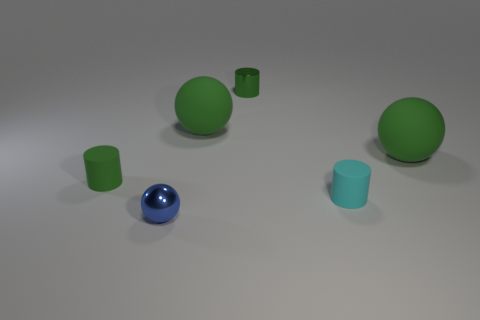What is the big green sphere left of the matte object that is on the right side of the tiny cyan cylinder made of?
Give a very brief answer. Rubber. Is there anything else that is the same size as the green rubber cylinder?
Your answer should be very brief. Yes. Do the cyan cylinder and the green cylinder that is to the right of the blue thing have the same material?
Ensure brevity in your answer.  No. What is the material of the sphere that is behind the tiny cyan object and on the left side of the cyan thing?
Provide a succinct answer. Rubber. There is a big thing behind the green rubber object to the right of the small cyan cylinder; what color is it?
Your response must be concise. Green. There is a ball that is in front of the tiny cyan cylinder; what is its material?
Give a very brief answer. Metal. Is the number of red metallic objects less than the number of small cyan matte objects?
Give a very brief answer. Yes. Does the tiny cyan object have the same shape as the tiny shiny object on the right side of the blue ball?
Ensure brevity in your answer.  Yes. There is a matte thing that is both on the right side of the green metal thing and behind the green rubber cylinder; what shape is it?
Make the answer very short. Sphere. Is the number of green balls that are in front of the tiny cyan rubber cylinder the same as the number of cylinders to the left of the tiny metallic cylinder?
Provide a succinct answer. No. 